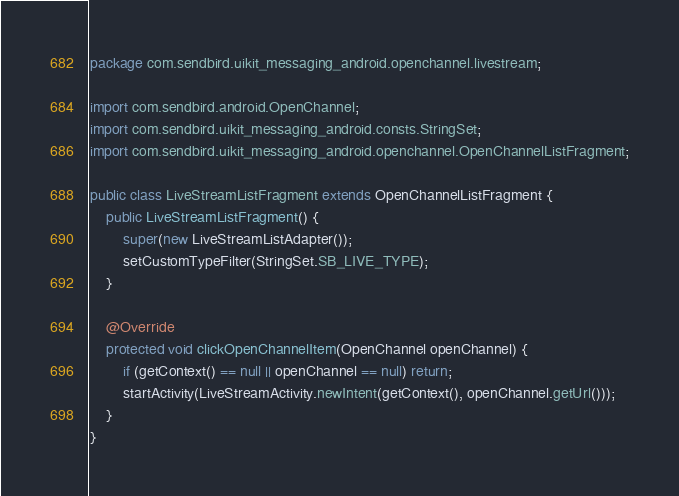Convert code to text. <code><loc_0><loc_0><loc_500><loc_500><_Java_>package com.sendbird.uikit_messaging_android.openchannel.livestream;

import com.sendbird.android.OpenChannel;
import com.sendbird.uikit_messaging_android.consts.StringSet;
import com.sendbird.uikit_messaging_android.openchannel.OpenChannelListFragment;

public class LiveStreamListFragment extends OpenChannelListFragment {
    public LiveStreamListFragment() {
        super(new LiveStreamListAdapter());
        setCustomTypeFilter(StringSet.SB_LIVE_TYPE);
    }

    @Override
    protected void clickOpenChannelItem(OpenChannel openChannel) {
        if (getContext() == null || openChannel == null) return;
        startActivity(LiveStreamActivity.newIntent(getContext(), openChannel.getUrl()));
    }
}
</code> 